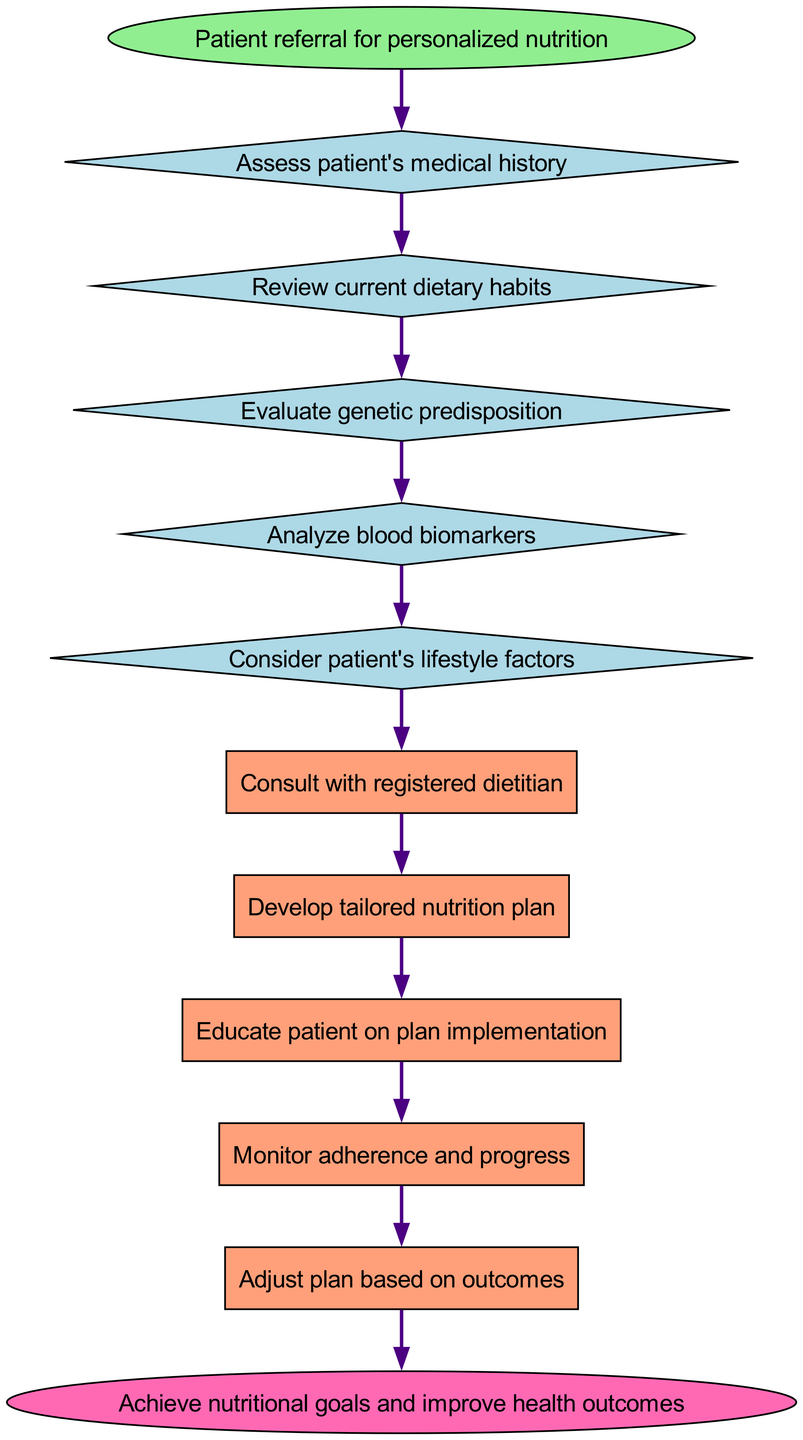What is the starting point of the pathway? The starting point, or the first node in the pathway, is labeled as "Patient referral for personalized nutrition".
Answer: Patient referral for personalized nutrition How many decision nodes are there in the pathway? The diagram lists five decision nodes, which are all critical points where evaluations are made before proceeding.
Answer: 5 What follows after assessing the patient's medical history? After assessing the patient's medical history, the next process is to "Review current dietary habits" as indicated in the connections.
Answer: Review current dietary habits Which node directly leads to the consultation with a registered dietitian? The node that connects directly to "Consult with registered dietitian" is "Consider patient's lifestyle factors".
Answer: Consider patient's lifestyle factors What is the final goal of the clinical pathway? The end node of the pathway states that the ultimate goal is to "Achieve nutritional goals and improve health outcomes".
Answer: Achieve nutritional goals and improve health outcomes How many process nodes are there in total? The diagram includes five distinct process nodes that represent actions taken after the decision points.
Answer: 5 What node comes directly after educating the patient on plan implementation? The node that follows "Educate patient on plan implementation" is "Monitor adherence and progress", indicating the next step in the process.
Answer: Monitor adherence and progress In what sequence do blood biomarkers and lifestyle factors occur? Blood biomarkers are analyzed before considering lifestyle factors, as the pathway flows from "Analyze blood biomarkers" to "Consider patient's lifestyle factors".
Answer: Analyze blood biomarkers to Consider patient's lifestyle factors What is the connection between evaluating genetic predisposition and analyzing blood biomarkers? Evaluating genetic predisposition is directly followed by analyzing blood biomarkers, forming a logical flow from one step to the next.
Answer: Evaluating genetic predisposition to Analyze blood biomarkers 